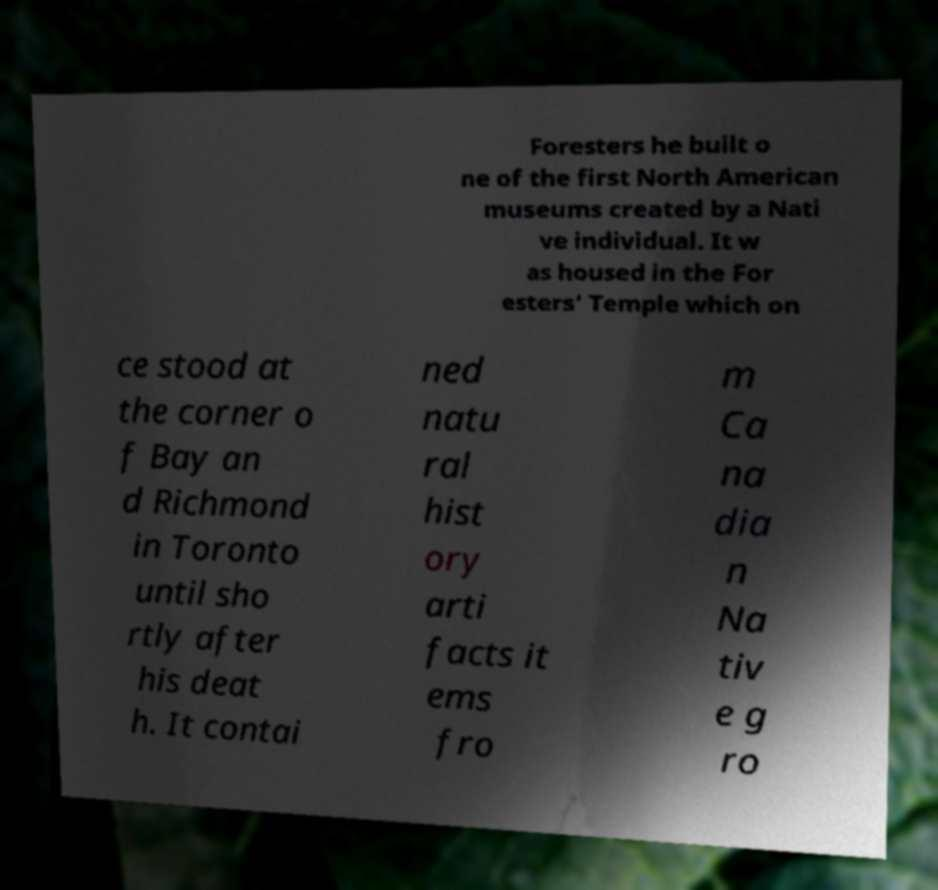Please identify and transcribe the text found in this image. Foresters he built o ne of the first North American museums created by a Nati ve individual. It w as housed in the For esters' Temple which on ce stood at the corner o f Bay an d Richmond in Toronto until sho rtly after his deat h. It contai ned natu ral hist ory arti facts it ems fro m Ca na dia n Na tiv e g ro 